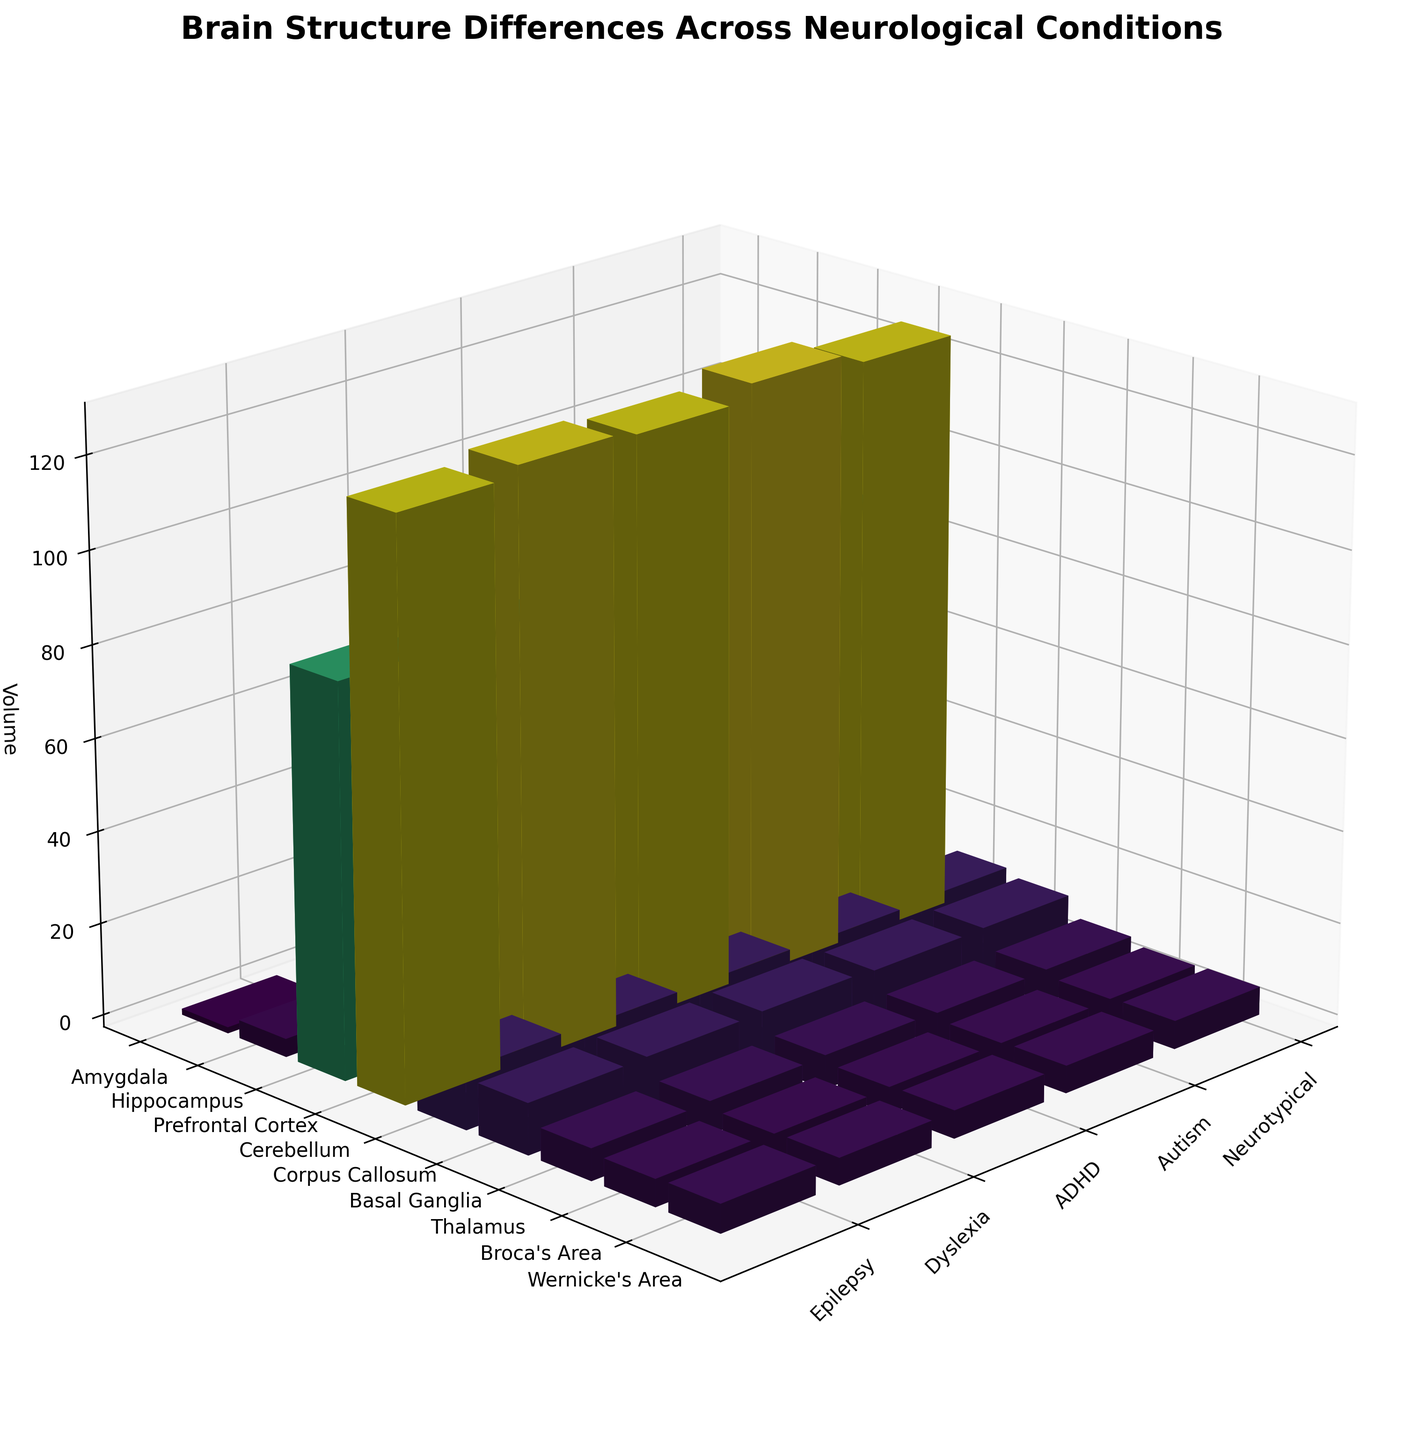How many neurological conditions are compared in the figure? The x-axis of the 3D plot labels the different neurological conditions being compared. You can count the labels to determine the number.
Answer: 5 What is the title of the figure? The title is usually located at the top of the figure and serves as a brief summary of the content.
Answer: Brain Structure Differences Across Neurological Conditions Which brain region has the highest volume in neurotypical individuals? By observing the bars corresponding to the 'Neurotypical' condition for each brain region, identify the tallest bar.
Answer: Cerebellum Which neurological condition shows the smallest volume for the Amygdala? Locate the bars for the Amygdala across all neurological conditions and identify the shortest bar.
Answer: Epilepsy What is the average volume of the Basal Ganglia across all conditions? Sum the volumes of the Basal Ganglia for each condition and divide by the number of conditions: (11.4 + 11.2 + 11.6 + 11.3 + 11.1)/5 = 56.6/5 = 11.32
Answer: 11.32 How does the volume of the Corpus Callosum in individuals with ADHD compare to those with Neurotypical condition? Check the height of the bars for the Corpus Callosum in both 'Neurotypical' and 'ADHD' conditions, and compare their volumes.
Answer: Lower Which brain region shows the largest variation in volume across the different conditions? Look at the range of bar heights for each brain region across all conditions and identify the one with the widest range.
Answer: Cerebellum What is the volume difference of the Hippocampus between Dyslexia and Epilepsy? Subtract the volume of the Hippocampus for Epilepsy from the volume for Dyslexia: 4.3 - 3.9 = 0.4
Answer: 0.4 In which neurological condition is Wernicke's Area the largest, and what is its volume? By examining the bars corresponding to Wernicke’s Area, identify the condition with the tallest bar and note its volume.
Answer: Epilepsy, 6.2 Do the volumes of the Prefrontal Cortex show any noticeable trend across the conditions? Observe the heights of the bars representing Prefrontal Cortex volumes and see if there's a pattern, e.g., increasing, decreasing, or varying randomly.
Answer: Varying 